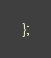Convert code to text. <code><loc_0><loc_0><loc_500><loc_500><_JavaScript_>};</code> 